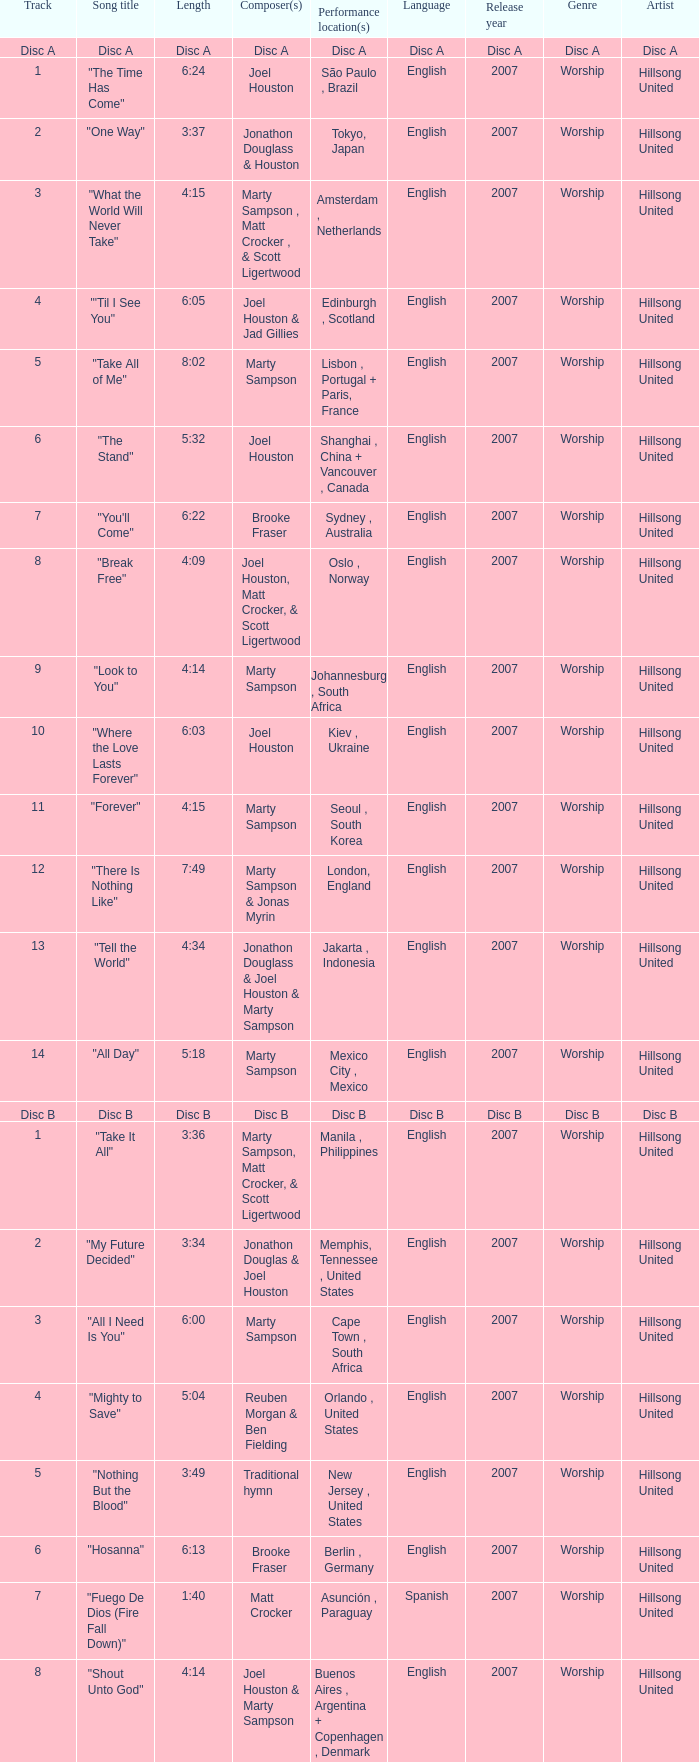Would you be able to parse every entry in this table? {'header': ['Track', 'Song title', 'Length', 'Composer(s)', 'Performance location(s)', 'Language', 'Release year', 'Genre', 'Artist'], 'rows': [['Disc A', 'Disc A', 'Disc A', 'Disc A', 'Disc A', 'Disc A', 'Disc A', 'Disc A', 'Disc A'], ['1', '"The Time Has Come"', '6:24', 'Joel Houston', 'São Paulo , Brazil', 'English', '2007', 'Worship', 'Hillsong United'], ['2', '"One Way"', '3:37', 'Jonathon Douglass & Houston', 'Tokyo, Japan', 'English', '2007', 'Worship', 'Hillsong United'], ['3', '"What the World Will Never Take"', '4:15', 'Marty Sampson , Matt Crocker , & Scott Ligertwood', 'Amsterdam , Netherlands', 'English', '2007', 'Worship', 'Hillsong United'], ['4', '"\'Til I See You"', '6:05', 'Joel Houston & Jad Gillies', 'Edinburgh , Scotland', 'English', '2007', 'Worship', 'Hillsong United'], ['5', '"Take All of Me"', '8:02', 'Marty Sampson', 'Lisbon , Portugal + Paris, France', 'English', '2007', 'Worship', 'Hillsong United'], ['6', '"The Stand"', '5:32', 'Joel Houston', 'Shanghai , China + Vancouver , Canada', 'English', '2007', 'Worship', 'Hillsong United'], ['7', '"You\'ll Come"', '6:22', 'Brooke Fraser', 'Sydney , Australia', 'English', '2007', 'Worship', 'Hillsong United'], ['8', '"Break Free"', '4:09', 'Joel Houston, Matt Crocker, & Scott Ligertwood', 'Oslo , Norway', 'English', '2007', 'Worship', 'Hillsong United'], ['9', '"Look to You"', '4:14', 'Marty Sampson', 'Johannesburg , South Africa', 'English', '2007', 'Worship', 'Hillsong United'], ['10', '"Where the Love Lasts Forever"', '6:03', 'Joel Houston', 'Kiev , Ukraine', 'English', '2007', 'Worship', 'Hillsong United'], ['11', '"Forever"', '4:15', 'Marty Sampson', 'Seoul , South Korea', 'English', '2007', 'Worship', 'Hillsong United'], ['12', '"There Is Nothing Like"', '7:49', 'Marty Sampson & Jonas Myrin', 'London, England', 'English', '2007', 'Worship', 'Hillsong United'], ['13', '"Tell the World"', '4:34', 'Jonathon Douglass & Joel Houston & Marty Sampson', 'Jakarta , Indonesia', 'English', '2007', 'Worship', 'Hillsong United'], ['14', '"All Day"', '5:18', 'Marty Sampson', 'Mexico City , Mexico', 'English', '2007', 'Worship', 'Hillsong United'], ['Disc B', 'Disc B', 'Disc B', 'Disc B', 'Disc B', 'Disc B', 'Disc B', 'Disc B', 'Disc B'], ['1', '"Take It All"', '3:36', 'Marty Sampson, Matt Crocker, & Scott Ligertwood', 'Manila , Philippines', 'English', '2007', 'Worship', 'Hillsong United'], ['2', '"My Future Decided"', '3:34', 'Jonathon Douglas & Joel Houston', 'Memphis, Tennessee , United States', 'English', '2007', 'Worship', 'Hillsong United'], ['3', '"All I Need Is You"', '6:00', 'Marty Sampson', 'Cape Town , South Africa', 'English', '2007', 'Worship', 'Hillsong United'], ['4', '"Mighty to Save"', '5:04', 'Reuben Morgan & Ben Fielding', 'Orlando , United States', 'English', '2007', 'Worship', 'Hillsong United'], ['5', '"Nothing But the Blood"', '3:49', 'Traditional hymn', 'New Jersey , United States', 'English', '2007', 'Worship', 'Hillsong United'], ['6', '"Hosanna"', '6:13', 'Brooke Fraser', 'Berlin , Germany', 'English', '2007', 'Worship', 'Hillsong United'], ['7', '"Fuego De Dios (Fire Fall Down)"', '1:40', 'Matt Crocker', 'Asunción , Paraguay', 'Spanish', '2007', 'Worship', 'Hillsong United'], ['8', '"Shout Unto God"', '4:14', 'Joel Houston & Marty Sampson', 'Buenos Aires , Argentina + Copenhagen , Denmark', 'English', '2007', 'Worship', 'Hillsong United'], ['9', '"Salvation Is Here"', '4:03', 'Joel Houston', 'Budapest , Hungary', 'English', '2007', 'Worship', 'Hillsong United'], ['10', '"Love Enough"', '3:04', 'Braden Lang & Scott Ligertwood', 'Sydney, Australia', 'English', '2007', 'Worship', 'Hillsong United'], ['11', '"More Than Life"', '6:29', 'Morgan', 'Orlando, United States', 'English', '2007', 'Worship', 'Hillsong United'], ['12', '"None But Jesus"', '7:58', 'Brooke Fraser', 'Toronto , Canada + Buenos Aires, Argentina', 'English', '2007', 'Worship', 'Hillsong United'], ['13', '"From the Inside Out"', '5:59', 'Joel Houston', 'Rio de Janeiro , Brazil', 'English', '2007', 'Worship', 'Hillsong United'], ['14', '"Came to My Rescue"', '3:43', 'Marty Sampson, Dylan Thomas, & Joel Davies', 'Kuala Lumpur , Malaysia', 'English', '2007', 'Worship', 'Hillsong United'], ['15', '"Saviour King"', '7:03', 'Marty Sampson & Mia Fieldes', 'Västerås , Sweden', 'English', '2007', 'Worship', 'Hillsong United'], ['16', '"Solution"', '5:55', 'Joel Houston & Matt Crocker', 'Los Angeles , United States', 'English', '2007', 'Worship', 'Hillsong United']]} Who is the composer of the song with a length of 6:24? Joel Houston. 